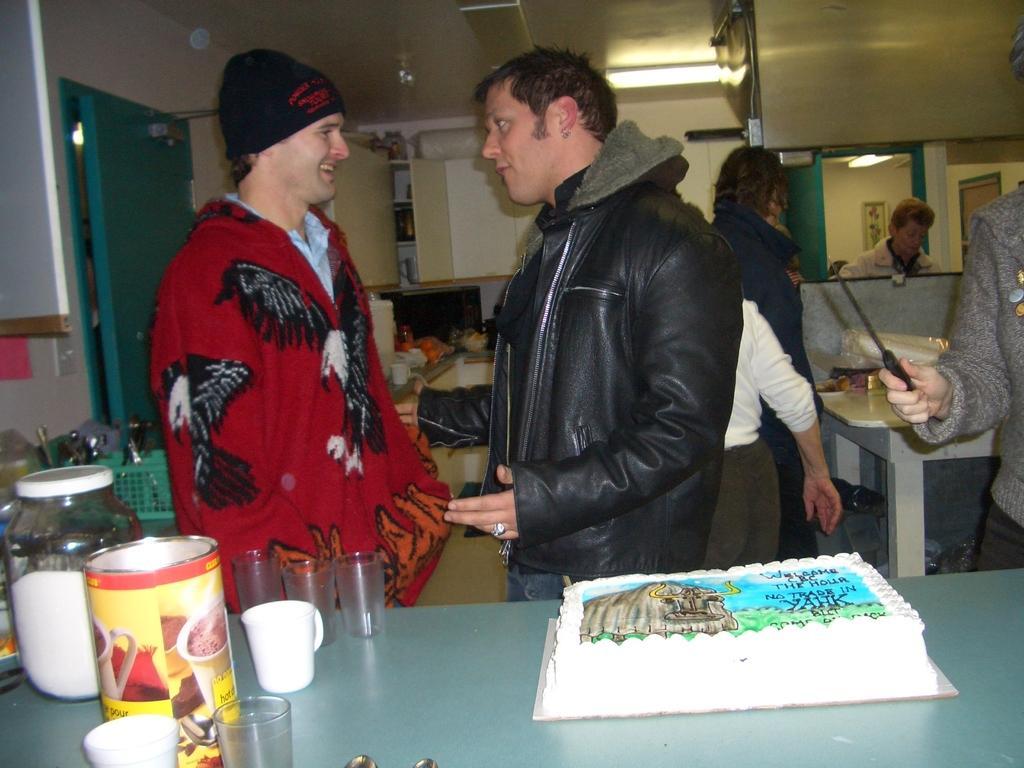How would you summarize this image in a sentence or two? In this image I can see a cake, glasses and other items in the front. People are standing and there are lights at the top. There are doors. 